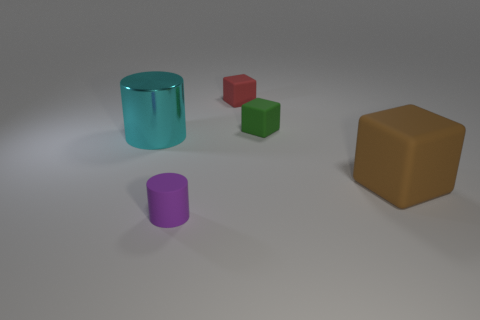Add 1 large yellow matte objects. How many objects exist? 6 Subtract all cylinders. How many objects are left? 3 Subtract 0 gray cylinders. How many objects are left? 5 Subtract all large blue rubber cylinders. Subtract all large cylinders. How many objects are left? 4 Add 5 large cylinders. How many large cylinders are left? 6 Add 1 cylinders. How many cylinders exist? 3 